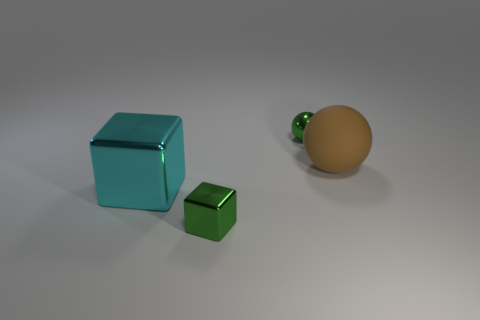Add 1 large rubber balls. How many objects exist? 5 Add 1 green metallic things. How many green metallic things exist? 3 Subtract 0 brown cylinders. How many objects are left? 4 Subtract all small gray metallic cylinders. Subtract all small shiny blocks. How many objects are left? 3 Add 2 big cyan objects. How many big cyan objects are left? 3 